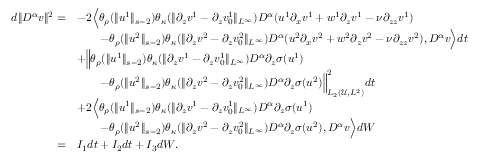<formula> <loc_0><loc_0><loc_500><loc_500>\begin{array} { r l } { d \| D ^ { \alpha } v \| ^ { 2 } = } & { - 2 \left \langle \theta _ { \rho } ( \| u ^ { 1 } \| _ { s - 2 } ) \theta _ { \kappa } ( \| \partial _ { z } v ^ { 1 } - \partial _ { z } v _ { 0 } ^ { 1 } \| _ { L ^ { \infty } } ) D ^ { \alpha } ( u ^ { 1 } \partial _ { x } v ^ { 1 } + w ^ { 1 } \partial _ { z } v ^ { 1 } - \nu \partial _ { z z } v ^ { 1 } ) } \\ & { \quad - \theta _ { \rho } ( \| u ^ { 2 } \| _ { s - 2 } ) \theta _ { \kappa } ( \| \partial _ { z } v ^ { 2 } - \partial _ { z } v _ { 0 } ^ { 2 } \| _ { L ^ { \infty } } ) D ^ { \alpha } ( u ^ { 2 } \partial _ { x } v ^ { 2 } + w ^ { 2 } \partial _ { z } v ^ { 2 } - \nu \partial _ { z z } v ^ { 2 } ) , D ^ { \alpha } v \right \rangle d t } \\ & { + \left \| \theta _ { \rho } ( \| u ^ { 1 } \| _ { s - 2 } ) \theta _ { \kappa } ( \| \partial _ { z } v ^ { 1 } - \partial _ { z } v _ { 0 } ^ { 1 } \| _ { L ^ { \infty } } ) D ^ { \alpha } \partial _ { z } \sigma ( u ^ { 1 } ) } \\ & { \quad - \theta _ { \rho } ( \| u ^ { 2 } \| _ { s - 2 } ) \theta _ { \kappa } ( \| \partial _ { z } v ^ { 2 } - \partial _ { z } v _ { 0 } ^ { 2 } \| _ { L ^ { \infty } } ) D ^ { \alpha } \partial _ { z } \sigma ( u ^ { 2 } ) \right \| _ { L _ { 2 } ( \ m a t h s c r U , L ^ { 2 } ) } ^ { 2 } d t } \\ & { + 2 \left \langle \theta _ { \rho } ( \| u ^ { 1 } \| _ { s - 2 } ) \theta _ { \kappa } ( \| \partial _ { z } v ^ { 1 } - \partial _ { z } v _ { 0 } ^ { 1 } \| _ { L ^ { \infty } } ) D ^ { \alpha } \partial _ { z } \sigma ( u ^ { 1 } ) } \\ & { \quad - \theta _ { \rho } ( \| u ^ { 2 } \| _ { s - 2 } ) \theta _ { \kappa } ( \| \partial _ { z } v ^ { 2 } - \partial _ { z } v _ { 0 } ^ { 2 } \| _ { L ^ { \infty } } ) D ^ { \alpha } \partial _ { z } \sigma ( u ^ { 2 } ) , D ^ { \alpha } v \right \rangle d W } \\ { = } & { I _ { 1 } d t + I _ { 2 } d t + I _ { 3 } d W . } \end{array}</formula> 